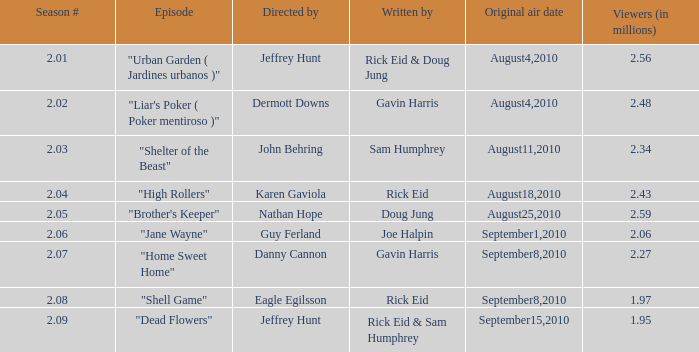What is the minimum value of the series when the season number is 2.08? 18.0. 